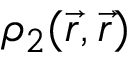<formula> <loc_0><loc_0><loc_500><loc_500>\rho _ { 2 } ( \vec { r } , \vec { r } )</formula> 